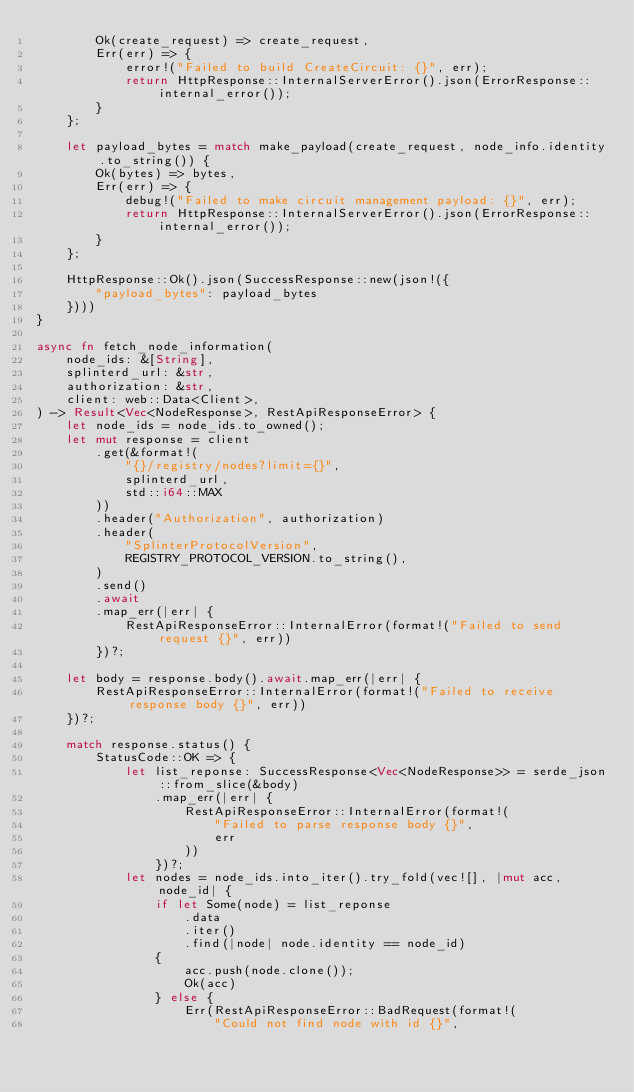Convert code to text. <code><loc_0><loc_0><loc_500><loc_500><_Rust_>        Ok(create_request) => create_request,
        Err(err) => {
            error!("Failed to build CreateCircuit: {}", err);
            return HttpResponse::InternalServerError().json(ErrorResponse::internal_error());
        }
    };

    let payload_bytes = match make_payload(create_request, node_info.identity.to_string()) {
        Ok(bytes) => bytes,
        Err(err) => {
            debug!("Failed to make circuit management payload: {}", err);
            return HttpResponse::InternalServerError().json(ErrorResponse::internal_error());
        }
    };

    HttpResponse::Ok().json(SuccessResponse::new(json!({
        "payload_bytes": payload_bytes
    })))
}

async fn fetch_node_information(
    node_ids: &[String],
    splinterd_url: &str,
    authorization: &str,
    client: web::Data<Client>,
) -> Result<Vec<NodeResponse>, RestApiResponseError> {
    let node_ids = node_ids.to_owned();
    let mut response = client
        .get(&format!(
            "{}/registry/nodes?limit={}",
            splinterd_url,
            std::i64::MAX
        ))
        .header("Authorization", authorization)
        .header(
            "SplinterProtocolVersion",
            REGISTRY_PROTOCOL_VERSION.to_string(),
        )
        .send()
        .await
        .map_err(|err| {
            RestApiResponseError::InternalError(format!("Failed to send request {}", err))
        })?;

    let body = response.body().await.map_err(|err| {
        RestApiResponseError::InternalError(format!("Failed to receive response body {}", err))
    })?;

    match response.status() {
        StatusCode::OK => {
            let list_reponse: SuccessResponse<Vec<NodeResponse>> = serde_json::from_slice(&body)
                .map_err(|err| {
                    RestApiResponseError::InternalError(format!(
                        "Failed to parse response body {}",
                        err
                    ))
                })?;
            let nodes = node_ids.into_iter().try_fold(vec![], |mut acc, node_id| {
                if let Some(node) = list_reponse
                    .data
                    .iter()
                    .find(|node| node.identity == node_id)
                {
                    acc.push(node.clone());
                    Ok(acc)
                } else {
                    Err(RestApiResponseError::BadRequest(format!(
                        "Could not find node with id {}",</code> 